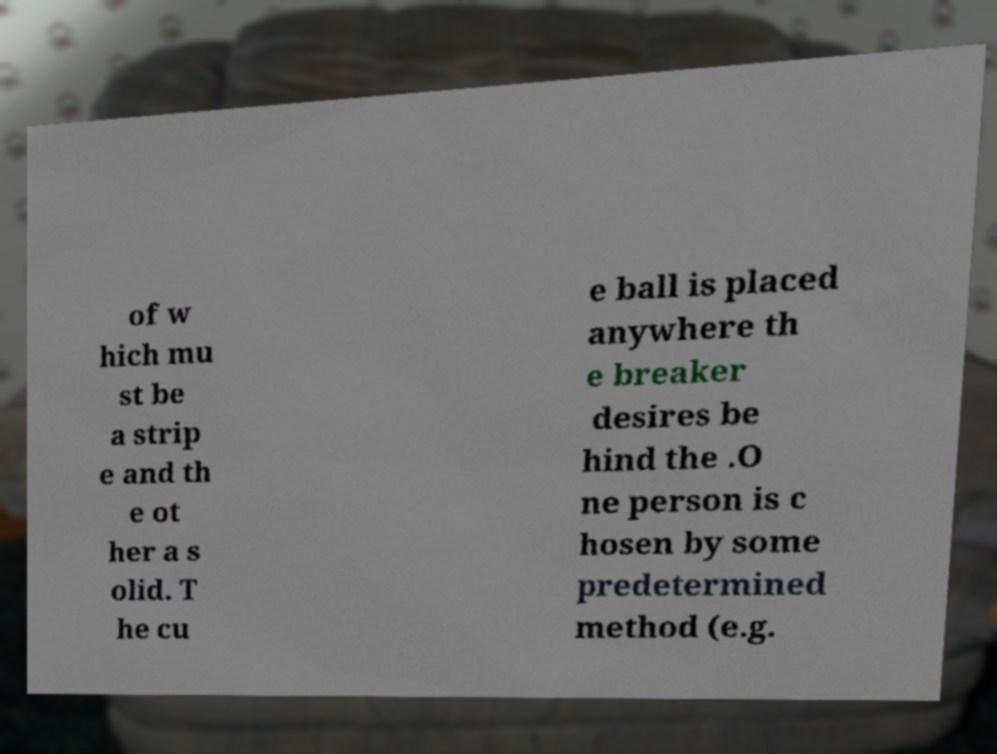Could you assist in decoding the text presented in this image and type it out clearly? of w hich mu st be a strip e and th e ot her a s olid. T he cu e ball is placed anywhere th e breaker desires be hind the .O ne person is c hosen by some predetermined method (e.g. 